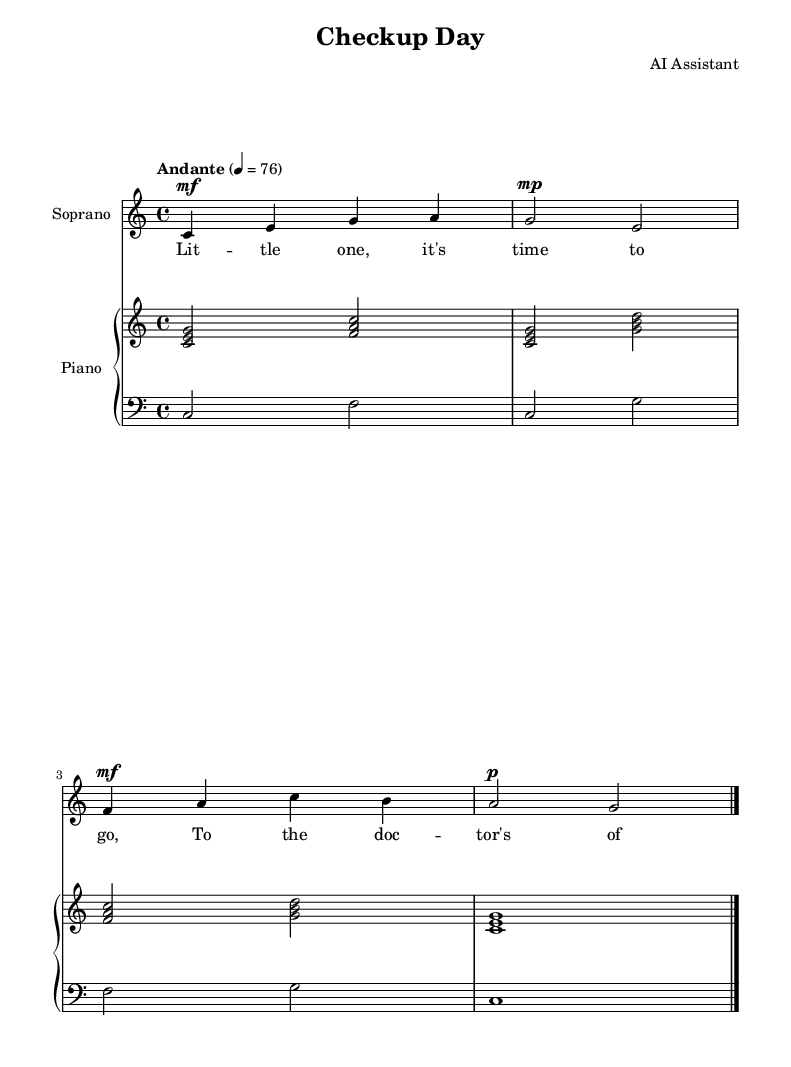What is the key signature of this music? The key signature is indicated at the beginning of the score and is C major, which has no sharps or flats.
Answer: C major What is the time signature of this music? The time signature is shown at the beginning of the score and is 4/4, indicating four beats per measure.
Answer: 4/4 What is the tempo marking for this piece? The tempo marking is found at the beginning of the score and indicates "Andante" with a metronome marking of 76 beats per minute, suggesting a moderate pace.
Answer: Andante, 76 How many measures are in the soprano part? The soprano part contains four measures, which can be counted from the beginning to the end of the music provided.
Answer: Four What dynamic marking is used at the beginning of the soprano part? The dynamic marking at the beginning of the soprano part is indicated as "mf," which stands for mezzo forte, meaning moderately loud.
Answer: mf What instruments are included in this score? The score includes a soprano voice and a piano, as indicated by the instrument names at the start of each staff.
Answer: Soprano and piano What phrase does the soprano lyric start with? The soprano lyric starts with "Lit -- tle one," which is visible in the lyrics under the music notes.
Answer: Lit -- tle one 